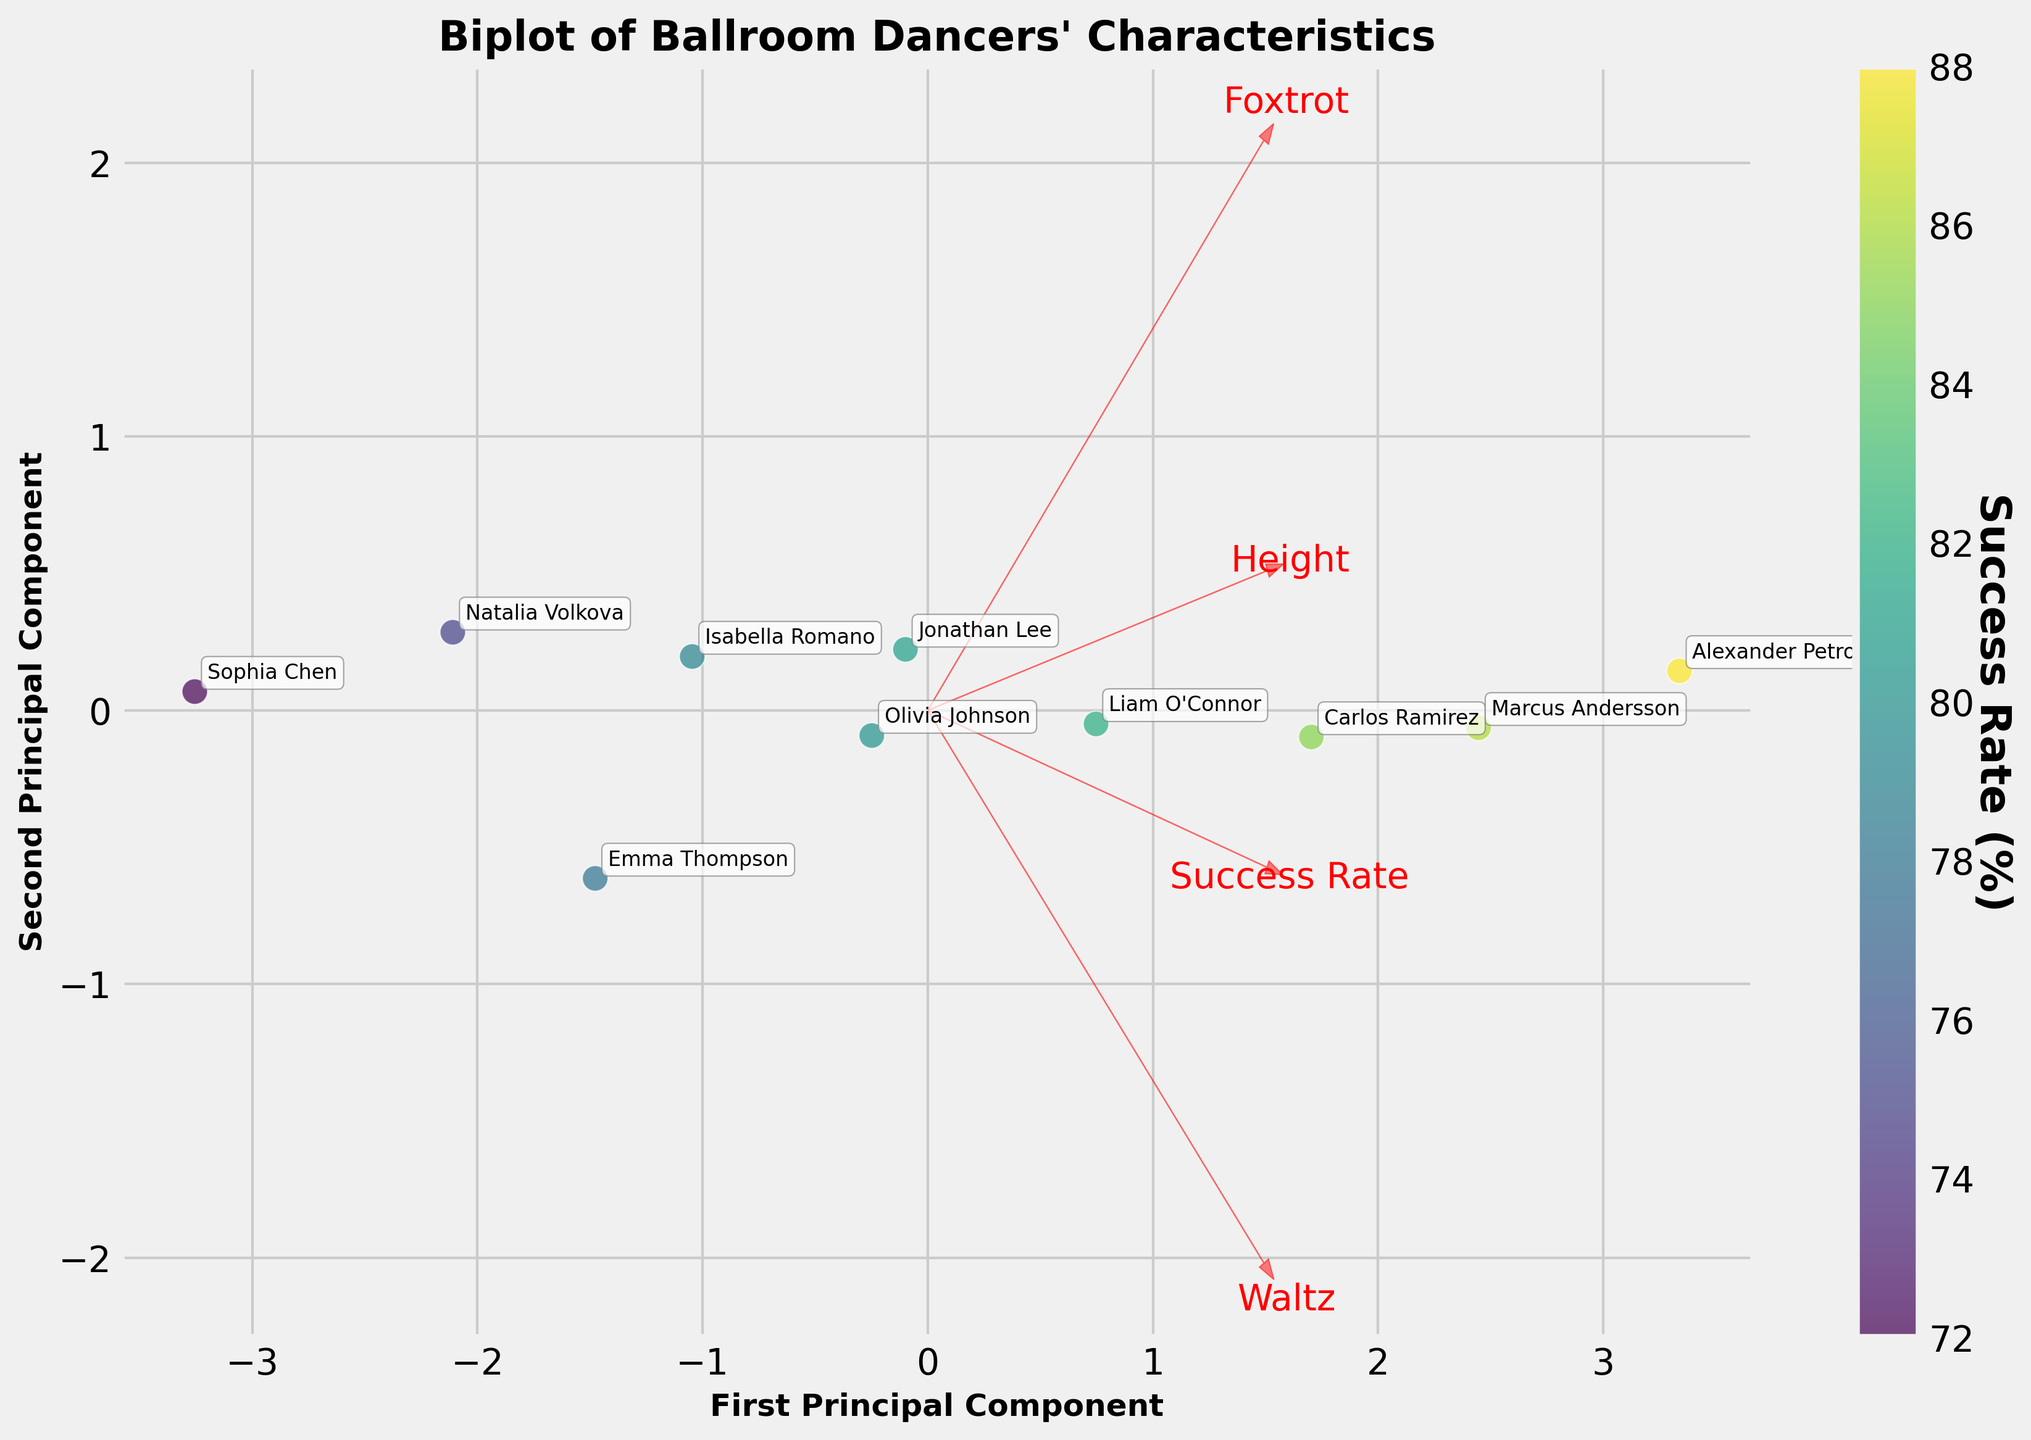How many dancers are represented in the plot? The plot has annotations for each dancer's name, and by counting these annotations, you can see there are 10 dancers.
Answer: 10 What does the color gradient in the data points represent? The color gradient of the data points, from the scatter plot and the corresponding color bar, represents the Success Rate (%).
Answer: Success Rate (%) Which arrow represents the 'Height' variable? The arrows in the plot have corresponding labels, and the arrow labeled 'Height' represents the 'Height' variable.
Answer: Arrow labeled 'Height' Which two variables are most closely aligned in the PCA biplot? By examining the angles between the feature vectors (arrows), the 'Waltz' and 'Foxtrot' variables are almost parallel, indicating they are most closely aligned.
Answer: Waltz and Foxtrot What is the range of the Success Rate (%) among the dancers as per the color bar? The color bar indicates the Success Rate (%) ranges from about 70% to 90%.
Answer: 70% to 90% Which dancer has the highest Success Rate (%) and how can you tell? By identifying the brightest color point on the scatter plot and checking the corresponding annotation, Alexander Petrov has the highest Success Rate (%).
Answer: Alexander Petrov Is there an observable trend between Height and Success Rate in the plot? Observing the scatter plot, taller dancers (like Carlos Ramirez and Alexander Petrov) generally appear to have higher Success Rates (%).
Answer: Taller dancers have higher Success Rates How are 'Waltz Score' and 'Success Rate (%)' related according to the PCA arrows? The 'Waltz' arrow and 'Success Rate' arrow point in nearly the same direction, indicating a positive correlation between Waltz Scores and Success Rate (%).
Answer: Positively correlated Which dancer appears closest to the center of the plot, and what does this imply? Jonathan Lee's annotation is nearest to the center, implying his attributes (Height, Success Rate (%), Waltz, and Foxtrot scores) are closest to the average dancer's attributes in the figure.
Answer: Jonathan Lee 